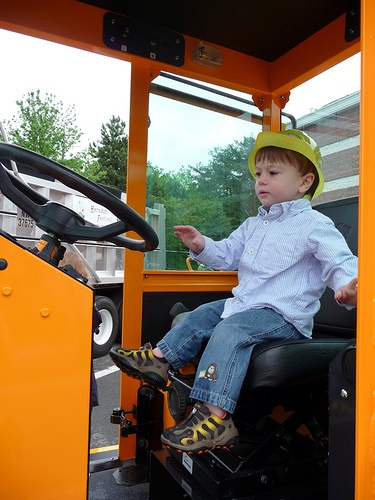Describe the objects in this image and their specific colors. I can see people in maroon, lightblue, darkgray, gray, and black tones and chair in maroon, black, blue, and purple tones in this image. 